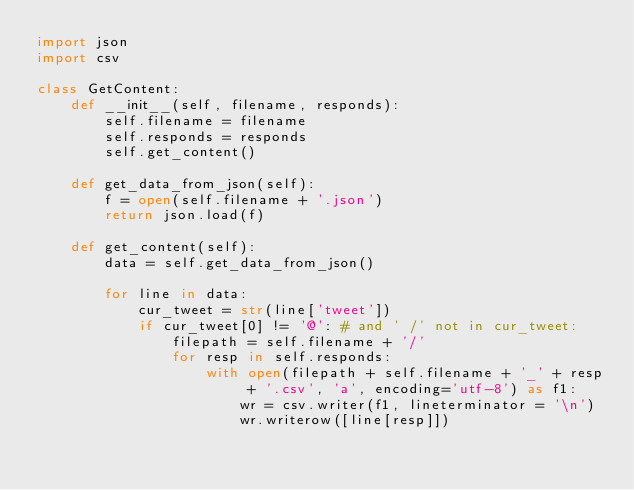<code> <loc_0><loc_0><loc_500><loc_500><_Python_>import json
import csv

class GetContent:
    def __init__(self, filename, responds):
        self.filename = filename
        self.responds = responds
        self.get_content()
    
    def get_data_from_json(self):
        f = open(self.filename + '.json')
        return json.load(f)

    def get_content(self):
        data = self.get_data_from_json()

        for line in data:
            cur_tweet = str(line['tweet'])
            if cur_tweet[0] != '@': # and ' /' not in cur_tweet:
                filepath = self.filename + '/'
                for resp in self.responds:
                    with open(filepath + self.filename + '_' + resp + '.csv', 'a', encoding='utf-8') as f1:
                        wr = csv.writer(f1, lineterminator = '\n')
                        wr.writerow([line[resp]])</code> 